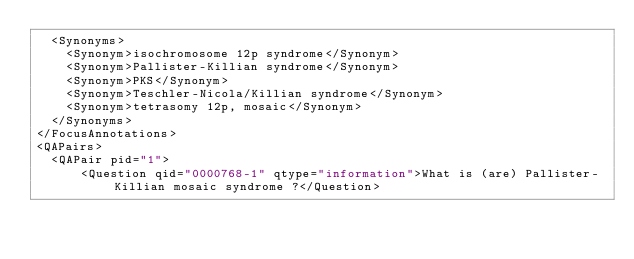<code> <loc_0><loc_0><loc_500><loc_500><_XML_>	<Synonyms>
		<Synonym>isochromosome 12p syndrome</Synonym>
		<Synonym>Pallister-Killian syndrome</Synonym>
		<Synonym>PKS</Synonym>
		<Synonym>Teschler-Nicola/Killian syndrome</Synonym>
		<Synonym>tetrasomy 12p, mosaic</Synonym>
	</Synonyms>
</FocusAnnotations>
<QAPairs>
	<QAPair pid="1">
			<Question qid="0000768-1" qtype="information">What is (are) Pallister-Killian mosaic syndrome ?</Question></code> 